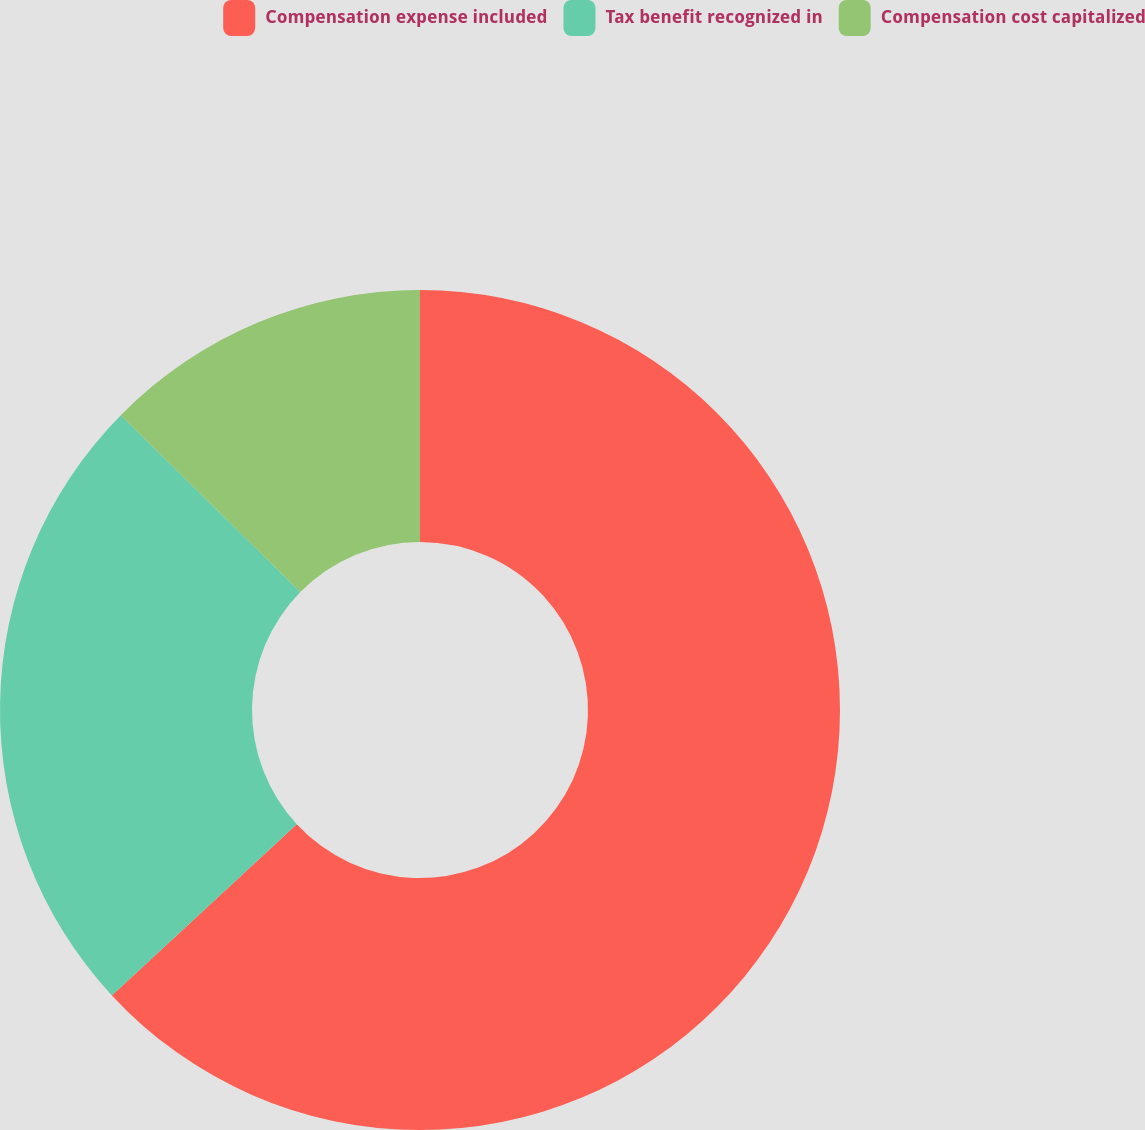<chart> <loc_0><loc_0><loc_500><loc_500><pie_chart><fcel>Compensation expense included<fcel>Tax benefit recognized in<fcel>Compensation cost capitalized<nl><fcel>63.11%<fcel>24.27%<fcel>12.62%<nl></chart> 